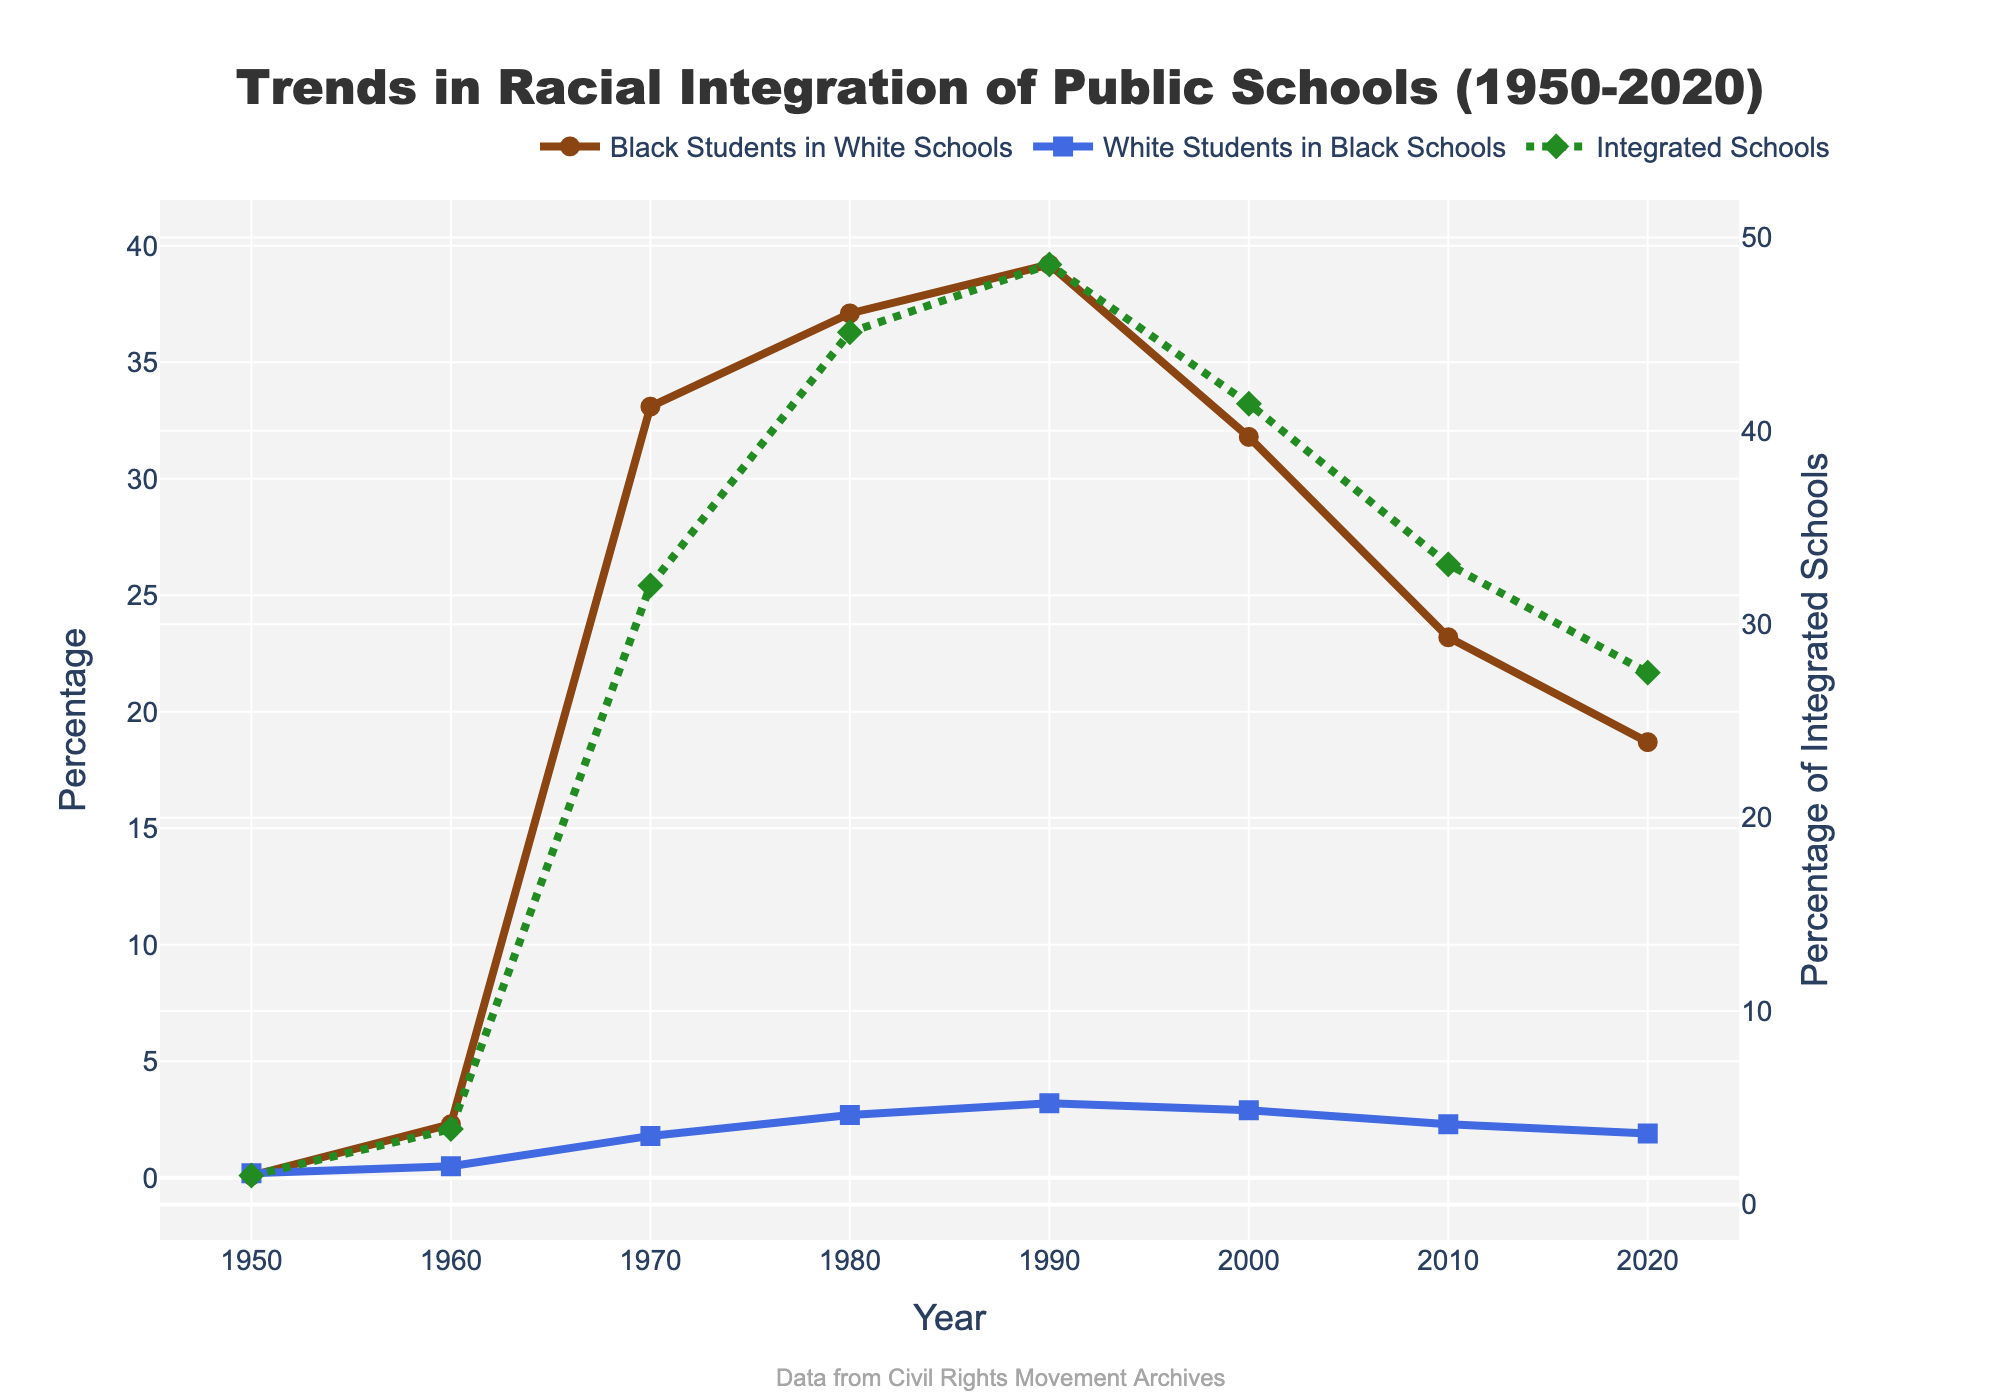What is the percentage increase in Black Students in Predominantly White Schools from 1960 to 1970? Looking at the figure, the percentage of Black Students in Predominantly White Schools in 1960 is 2.3% and in 1970 it is 33.1%. The percentage increase is calculated as (33.1 - 2.3) / 2.3 * 100%.
Answer: 1339.13% In which year did the Percentage of Integrated Schools reach its highest value and what was that value? The highest value of the Percentage of Integrated Schools can be observed in 1990, where it reached 48.6%.
Answer: 1990, 48.6% Compare the trend of Percentage of Black Students in Predominantly White Schools and Percentage of White Students in Predominantly Black Schools between 1980 and 2010. Which one saw a greater decline? From 1980 to 2010, the percentage of Black Students in Predominantly White Schools declined from 37.1% to 23.2%, a decrease of 13.9 percentage points. The percentage of White Students in Predominantly Black Schools declined from 2.7% to 2.3%, a decrease of 0.4 percentage points. Black Students in Predominantly White Schools saw a greater decline.
Answer: Black Students in Predominantly White Schools Which year shows the closest percentage between White Students in Predominantly Black Schools and Integrated Schools? What are these percentages? The closest percentages between White Students in Predominantly Black Schools and Integrated Schools are observed in 2020, with percentages at 1.9% and 27.5%, respectively.
Answer: 2020, 1.9% and 27.5% What is the average percentage of Integrated Schools from 1950 to 2020? The figure shows the percentage of Integrated Schools across various years: 1.5%, 3.9%, 32.0%, 45.1%, 48.6%, 41.4%, 33.1%, and 27.5%. The average is calculated by summing these percentages and dividing by the number of years, (1.5 + 3.9 + 32.0 + 45.1 + 48.6 + 41.4 + 33.1 + 27.5) / 8.
Answer: 29.14% Which year saw the largest increase in the Percentage of Black Students in Predominantly White Schools compared to the previous decade? The largest increase in the Percentage of Black Students in Predominantly White Schools is observed from 1960 to 1970, where it increased from 2.3% to 33.1%, a difference of 30.8 percentage points.
Answer: 1970 How does the trend in the Percentage of Integrated Schools relate to the percentage changes in Black and White Students in their respective Predominantly opposite-Racial Schools over time? From 1950 to 1990, as the percentage of Black Students in Predominantly White Schools and White Students in Predominantly Black Schools increased, the percentage of Integrated Schools also increased. After 1990, although the percentages of Black and White students in predominantly opposite-racial schools declined, the Percentage of Integrated Schools also saw a decline.
Answer: Correlated trends What is the difference in percentages of White Students in Predominantly Black Schools in 2000 and 2020? The figure shows that in 2000, the percentage of White Students in Predominantly Black Schools was 2.9%, and in 2020 it was 1.9%. The difference is calculated as 2.9 - 1.9.
Answer: 1% 